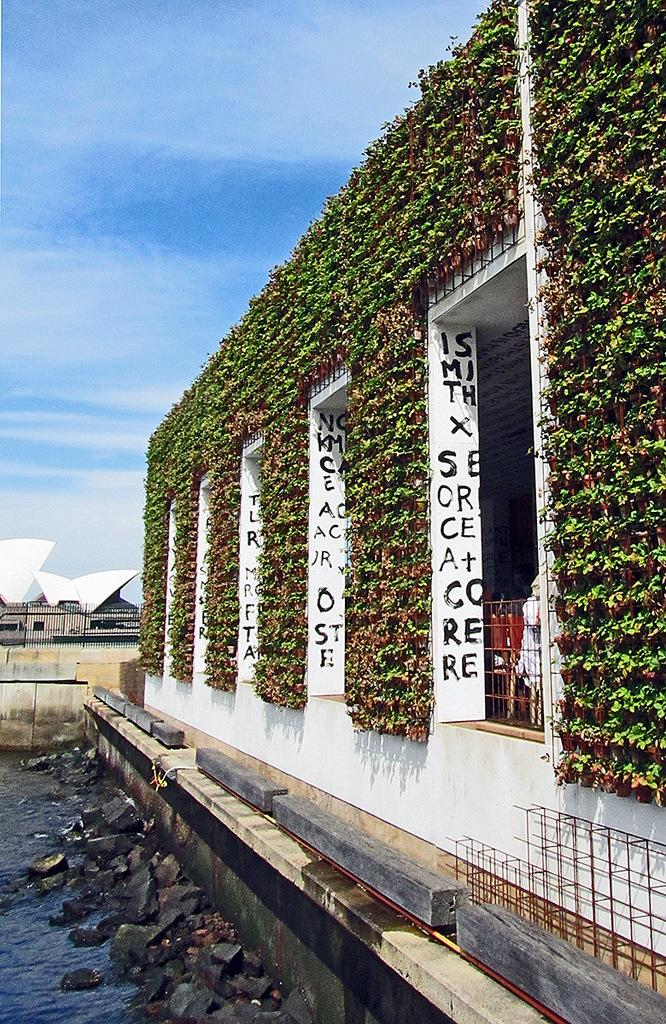What type of natural elements can be seen in the image? There are stones and water visible in the image. What type of vegetation is present in the image? House plants are present in the image. What type of man-made structures can be seen in the image? There are buildings, railings, walls, and rods visible in the image. What is visible in the background of the image? The sky is visible in the background of the image. Are there any other objects present in the image besides the ones mentioned? Yes, there are other objects in the image. What type of brush is being used by the porter in the image? There is no porter or brush present in the image. What type of roof is visible in the image? There is no roof visible in the image. 